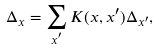Convert formula to latex. <formula><loc_0><loc_0><loc_500><loc_500>\Delta _ { x } = \sum _ { x ^ { ^ { \prime } } } K ( x , x ^ { \prime } ) \Delta _ { x ^ { \prime } } ,</formula> 